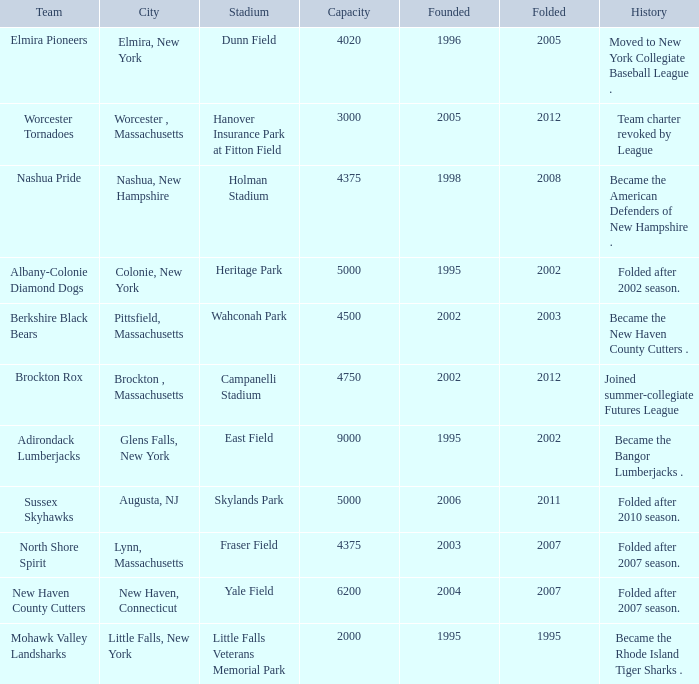What is the maximum folded value of the team whose stadium is Fraser Field? 2007.0. 